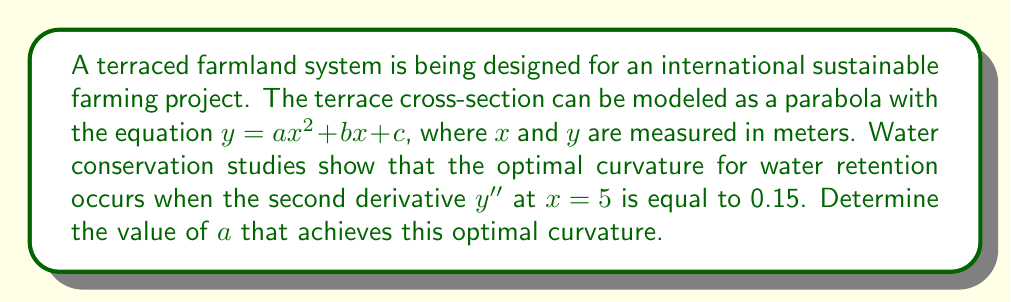Give your solution to this math problem. Let's approach this step-by-step:

1) The given equation for the terrace cross-section is:
   $y = ax^2 + bx + c$

2) To find the curvature, we need to calculate the second derivative of this function:
   $y' = 2ax + b$
   $y'' = 2a$

3) We're told that the optimal curvature occurs when $y'' = 0.15$ at $x = 5$:
   $y''(5) = 0.15$

4) Substituting the second derivative we found in step 2:
   $2a = 0.15$

5) Solving for $a$:
   $a = \frac{0.15}{2} = 0.075$

Therefore, the value of $a$ that achieves the optimal curvature is 0.075.
Answer: $a = 0.075$ 